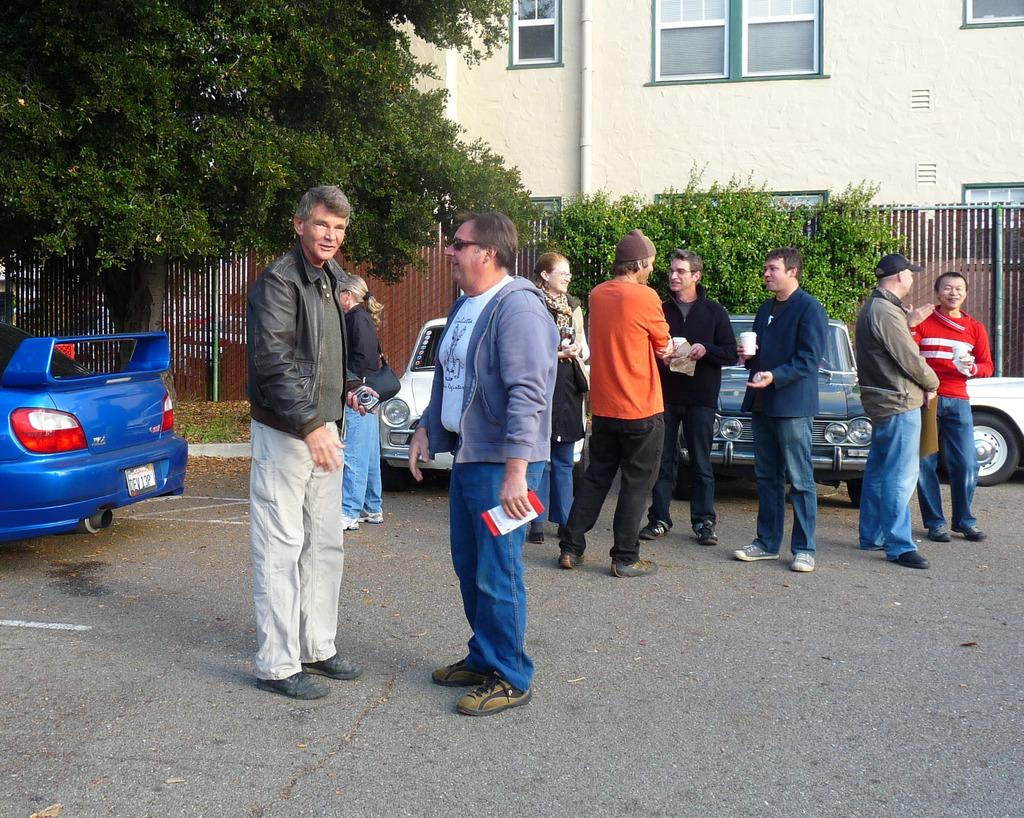What is the main feature of the image? There is a road in the image. What is happening on the road? There are cars on the road. Are there any people present in the image? Yes, there are people standing near the road. What can be seen in the background of the image? There is fencing, trees, plants, and a building in the background of the image. What type of egg is being used to make a wish in the image? There is no egg or wishing activity present in the image. What type of drink is being served to the people standing near the road? There is no drink or serving activity present in the image. 